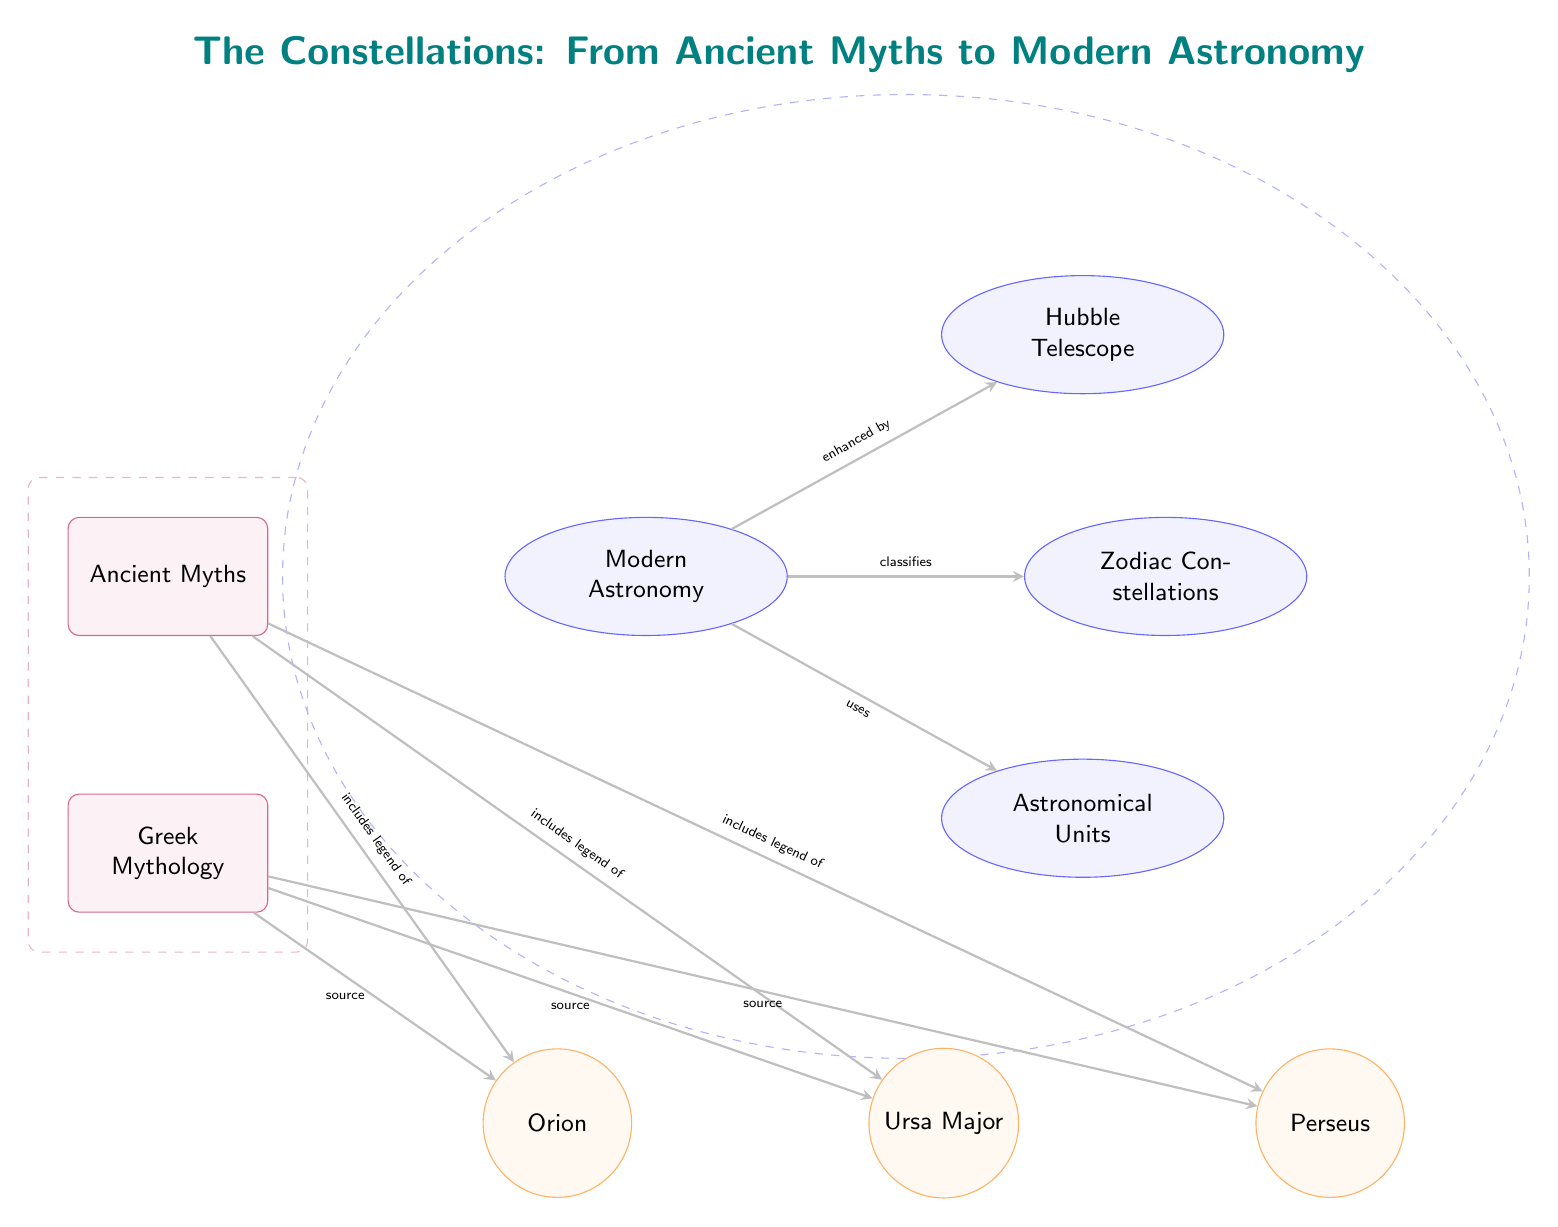What mythology is listed in the diagram? The diagram clearly identifies 'Greek Mythology' under the ancient category, which is indicated as a source for some constellations.
Answer: Greek Mythology How many constellations are mentioned in relation to Greek Mythology? The diagram shows three constellations that are linked to Greek Mythology: Orion, Ursa Major, and Perseus. This is indicated by the lines connecting them to the 'Greek Mythology' node.
Answer: Three Which astronomical tool is enhanced by modern astronomy? The diagram specifically mentions the 'Hubble Telescope' as an enhancement in modern astronomy, signified by an arrow pointing from 'Modern Astronomy' to 'Hubble Telescope'.
Answer: Hubble Telescope What relationship does the modern astronomy section have with astronomical units? The diagram shows a direct connection between 'Modern Astronomy' and 'Astronomical Units', labeled as 'uses', indicating that astronomical units are a tool utilized in modern astronomy.
Answer: uses Which node is a source for Orion? The diagram indicates that 'Greek Mythology' is the source for the constellation 'Orion', which is shown by the arrow pointing from 'Greek Mythology' to 'Orion'.
Answer: Greek Mythology What do the arrows in the diagram represent? The arrows represent relationships or connections between the various nodes, such as classifications, source references, and uses in the context of mythology and astronomy.
Answer: Relationships How many main categories are shown in the diagram? The diagram contains two main categories, labeled as 'Ancient Myths' and 'Modern Astronomy', which are clearly identified in the upper part of the diagram.
Answer: Two Which constellations are classified as zodiac constellations? The diagram indicates that 'Zodiac Constellations' is a category under modern astronomy but does not specify which constellations belong to this category. Thus, the answer remains focused on the general classification.
Answer: Zodiac Constellations Who provides legends for the constellations in the ancient category? The diagram illustrates that the constellations Orion, Ursa Major, and Perseus have their legends provided by 'Greek Mythology', as indicated by the connections.
Answer: Greek Mythology 